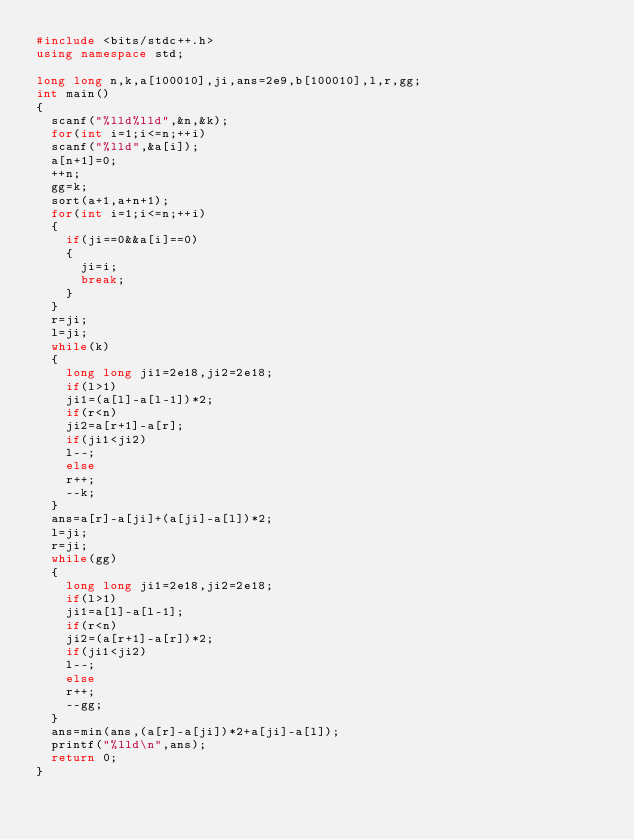<code> <loc_0><loc_0><loc_500><loc_500><_C++_>#include <bits/stdc++.h>
using namespace std;

long long n,k,a[100010],ji,ans=2e9,b[100010],l,r,gg;
int main()
{
	scanf("%lld%lld",&n,&k);
	for(int i=1;i<=n;++i)
	scanf("%lld",&a[i]);
	a[n+1]=0;
	++n;
	gg=k;
	sort(a+1,a+n+1);
	for(int i=1;i<=n;++i)
	{
		if(ji==0&&a[i]==0)
		{
			ji=i;
			break;
		}		
	}
	r=ji;
	l=ji;
	while(k)
	{
		long long ji1=2e18,ji2=2e18;
		if(l>1)
		ji1=(a[l]-a[l-1])*2;
		if(r<n)
		ji2=a[r+1]-a[r];
		if(ji1<ji2)
		l--;
		else
		r++;
		--k;
	}
	ans=a[r]-a[ji]+(a[ji]-a[l])*2;
	l=ji;
	r=ji;
	while(gg)
	{
		long long ji1=2e18,ji2=2e18;
		if(l>1)
		ji1=a[l]-a[l-1];
		if(r<n)
		ji2=(a[r+1]-a[r])*2;
		if(ji1<ji2)
		l--;
		else
		r++;
		--gg;
	}
	ans=min(ans,(a[r]-a[ji])*2+a[ji]-a[l]);
	printf("%lld\n",ans);
	return 0;
}</code> 